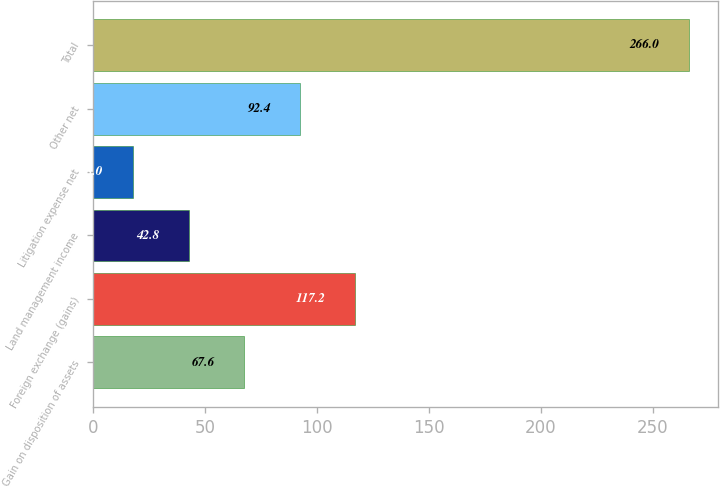<chart> <loc_0><loc_0><loc_500><loc_500><bar_chart><fcel>Gain on disposition of assets<fcel>Foreign exchange (gains)<fcel>Land management income<fcel>Litigation expense net<fcel>Other net<fcel>Total<nl><fcel>67.6<fcel>117.2<fcel>42.8<fcel>18<fcel>92.4<fcel>266<nl></chart> 